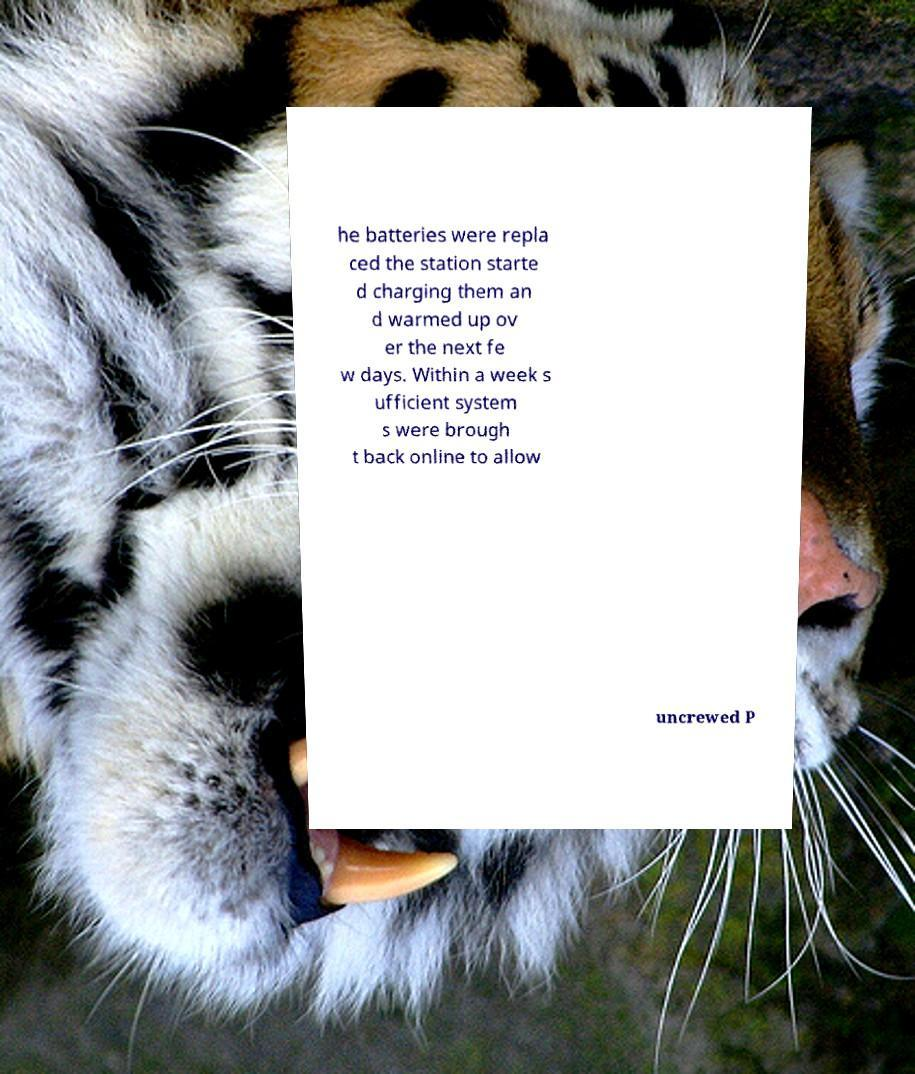For documentation purposes, I need the text within this image transcribed. Could you provide that? he batteries were repla ced the station starte d charging them an d warmed up ov er the next fe w days. Within a week s ufficient system s were brough t back online to allow uncrewed P 